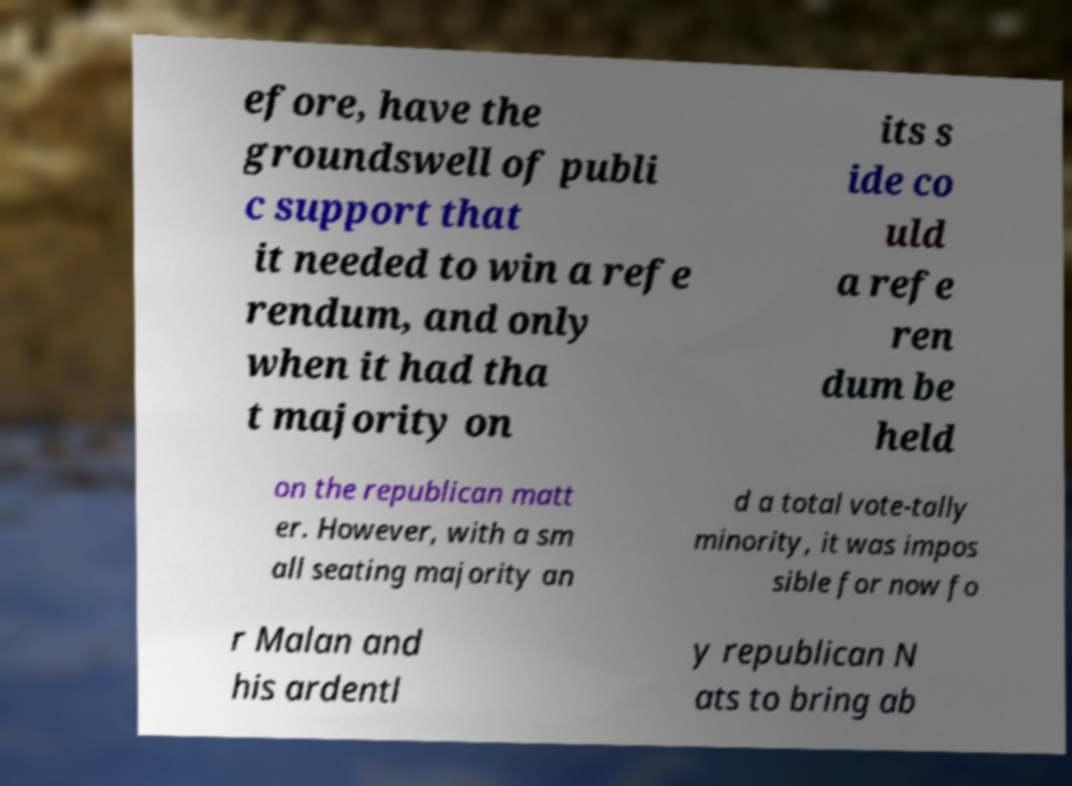What messages or text are displayed in this image? I need them in a readable, typed format. efore, have the groundswell of publi c support that it needed to win a refe rendum, and only when it had tha t majority on its s ide co uld a refe ren dum be held on the republican matt er. However, with a sm all seating majority an d a total vote-tally minority, it was impos sible for now fo r Malan and his ardentl y republican N ats to bring ab 